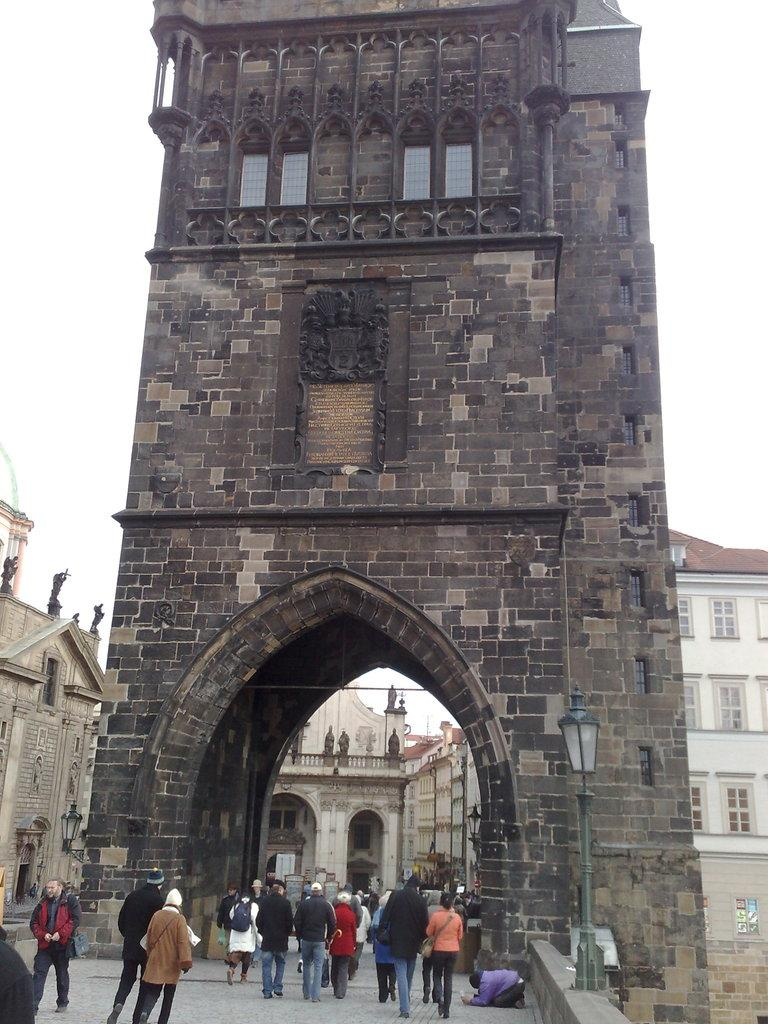What structures are located in the middle of the image? There are buildings in the middle of the image. What are the people in the image doing? There are persons walking at the bottom of the image. Where is the light coming from in the image? The light is on the right side of the image. What is visible at the top of the image? The sky is visible at the top of the image. What type of land can be seen in the image? There is no specific type of land mentioned or visible in the image. What smell is associated with the image? There is no information about smells in the image, as it is a visual medium. 